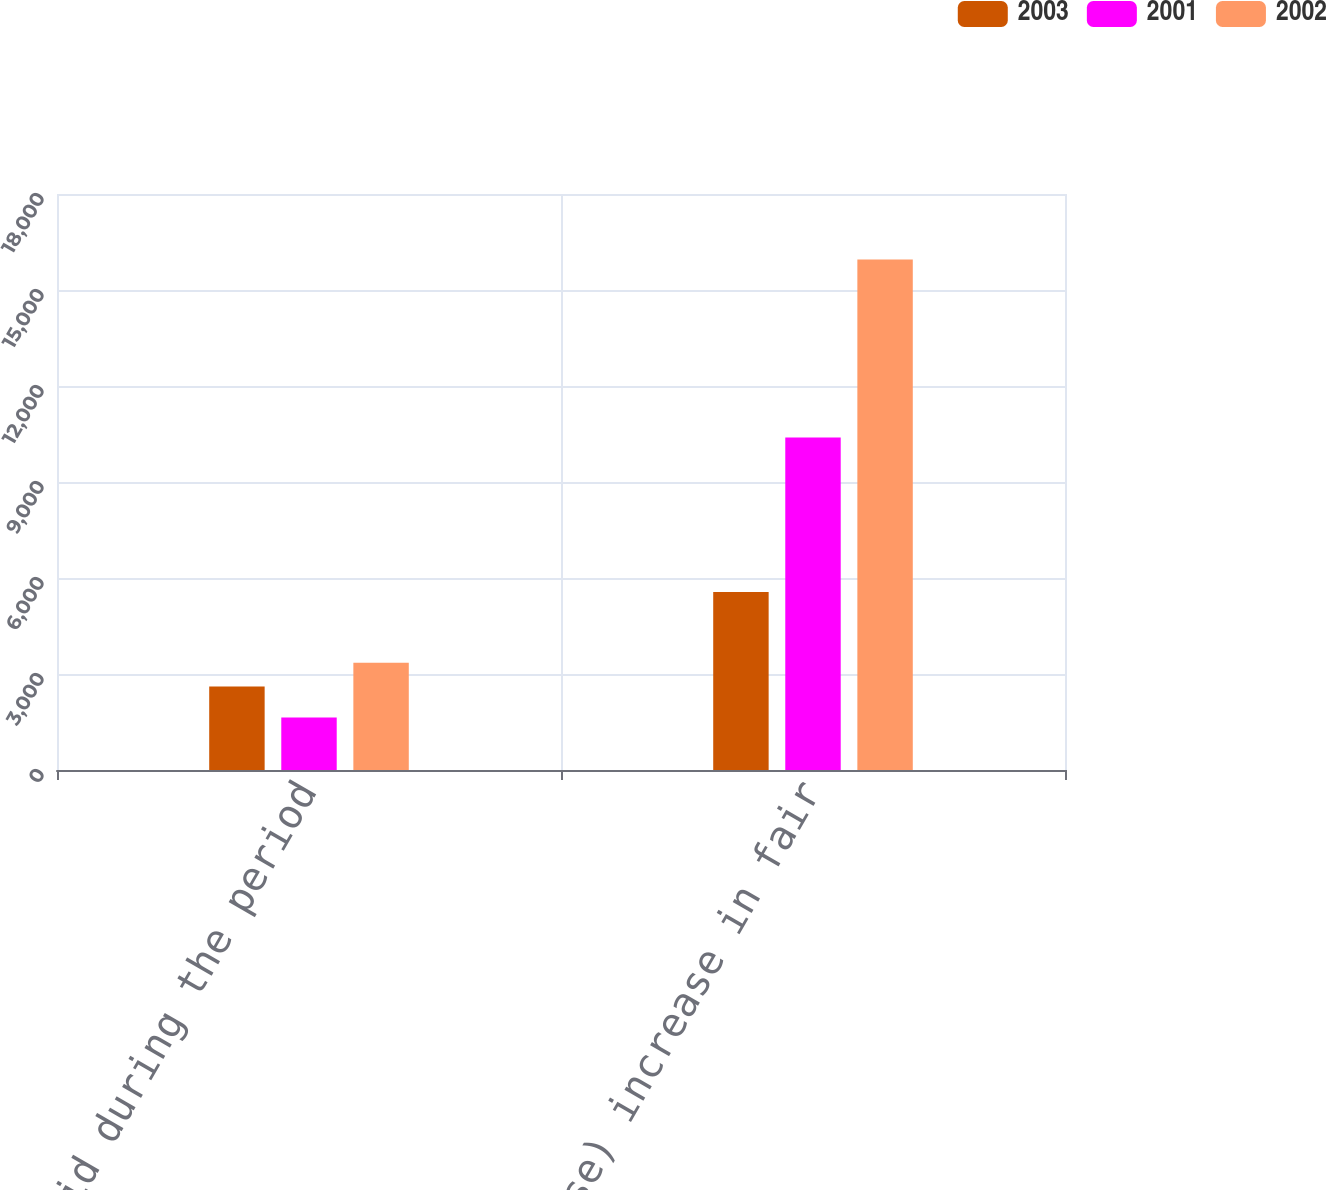Convert chart to OTSL. <chart><loc_0><loc_0><loc_500><loc_500><stacked_bar_chart><ecel><fcel>Cash paid during the period<fcel>(Decrease) increase in fair<nl><fcel>2003<fcel>2609<fcel>5564<nl><fcel>2001<fcel>1640<fcel>10389<nl><fcel>2002<fcel>3349<fcel>15953<nl></chart> 